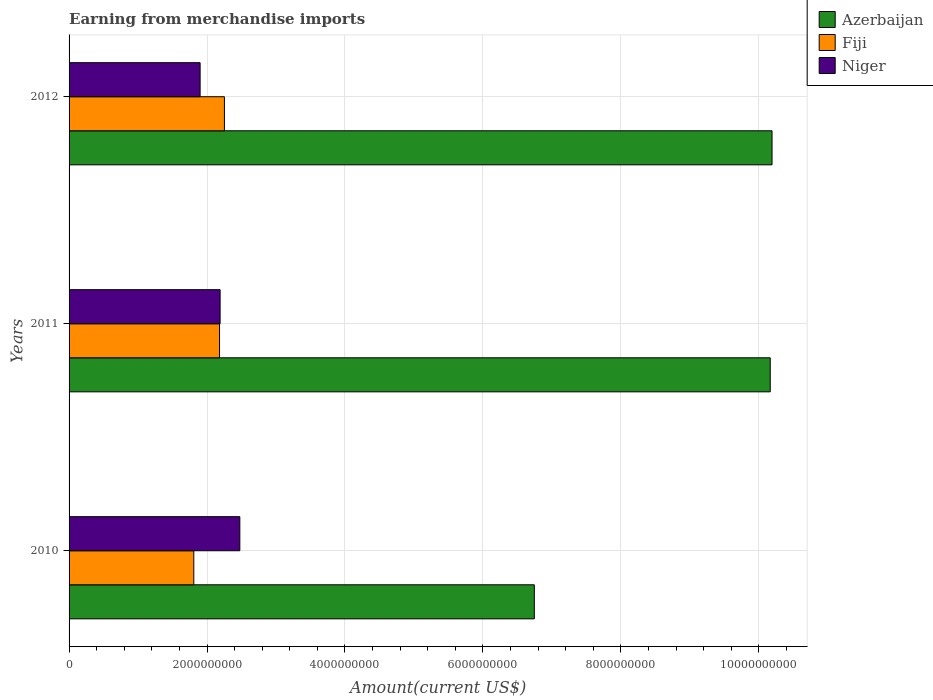How many different coloured bars are there?
Offer a very short reply. 3. How many groups of bars are there?
Your answer should be very brief. 3. Are the number of bars on each tick of the Y-axis equal?
Make the answer very short. Yes. What is the amount earned from merchandise imports in Fiji in 2010?
Ensure brevity in your answer.  1.81e+09. Across all years, what is the maximum amount earned from merchandise imports in Fiji?
Keep it short and to the point. 2.25e+09. Across all years, what is the minimum amount earned from merchandise imports in Fiji?
Provide a short and direct response. 1.81e+09. What is the total amount earned from merchandise imports in Fiji in the graph?
Ensure brevity in your answer.  6.24e+09. What is the difference between the amount earned from merchandise imports in Niger in 2010 and that in 2012?
Provide a succinct answer. 5.76e+08. What is the difference between the amount earned from merchandise imports in Azerbaijan in 2010 and the amount earned from merchandise imports in Niger in 2012?
Offer a terse response. 4.85e+09. What is the average amount earned from merchandise imports in Fiji per year?
Give a very brief answer. 2.08e+09. In the year 2012, what is the difference between the amount earned from merchandise imports in Fiji and amount earned from merchandise imports in Azerbaijan?
Provide a short and direct response. -7.94e+09. What is the ratio of the amount earned from merchandise imports in Azerbaijan in 2011 to that in 2012?
Your response must be concise. 1. Is the amount earned from merchandise imports in Fiji in 2010 less than that in 2012?
Your response must be concise. Yes. What is the difference between the highest and the second highest amount earned from merchandise imports in Niger?
Your response must be concise. 2.86e+08. What is the difference between the highest and the lowest amount earned from merchandise imports in Fiji?
Keep it short and to the point. 4.44e+08. In how many years, is the amount earned from merchandise imports in Niger greater than the average amount earned from merchandise imports in Niger taken over all years?
Offer a terse response. 2. Is the sum of the amount earned from merchandise imports in Niger in 2010 and 2011 greater than the maximum amount earned from merchandise imports in Azerbaijan across all years?
Offer a very short reply. No. What does the 1st bar from the top in 2010 represents?
Provide a short and direct response. Niger. What does the 2nd bar from the bottom in 2012 represents?
Give a very brief answer. Fiji. Are the values on the major ticks of X-axis written in scientific E-notation?
Your answer should be compact. No. Does the graph contain any zero values?
Keep it short and to the point. No. Where does the legend appear in the graph?
Offer a very short reply. Top right. How many legend labels are there?
Ensure brevity in your answer.  3. How are the legend labels stacked?
Offer a terse response. Vertical. What is the title of the graph?
Your answer should be compact. Earning from merchandise imports. What is the label or title of the X-axis?
Provide a succinct answer. Amount(current US$). What is the Amount(current US$) of Azerbaijan in 2010?
Your response must be concise. 6.75e+09. What is the Amount(current US$) of Fiji in 2010?
Provide a short and direct response. 1.81e+09. What is the Amount(current US$) of Niger in 2010?
Offer a terse response. 2.48e+09. What is the Amount(current US$) of Azerbaijan in 2011?
Your response must be concise. 1.02e+1. What is the Amount(current US$) in Fiji in 2011?
Provide a short and direct response. 2.18e+09. What is the Amount(current US$) of Niger in 2011?
Keep it short and to the point. 2.19e+09. What is the Amount(current US$) in Azerbaijan in 2012?
Your answer should be very brief. 1.02e+1. What is the Amount(current US$) in Fiji in 2012?
Give a very brief answer. 2.25e+09. What is the Amount(current US$) of Niger in 2012?
Offer a terse response. 1.90e+09. Across all years, what is the maximum Amount(current US$) in Azerbaijan?
Keep it short and to the point. 1.02e+1. Across all years, what is the maximum Amount(current US$) of Fiji?
Ensure brevity in your answer.  2.25e+09. Across all years, what is the maximum Amount(current US$) in Niger?
Make the answer very short. 2.48e+09. Across all years, what is the minimum Amount(current US$) in Azerbaijan?
Make the answer very short. 6.75e+09. Across all years, what is the minimum Amount(current US$) of Fiji?
Your response must be concise. 1.81e+09. Across all years, what is the minimum Amount(current US$) in Niger?
Keep it short and to the point. 1.90e+09. What is the total Amount(current US$) in Azerbaijan in the graph?
Your answer should be very brief. 2.71e+1. What is the total Amount(current US$) in Fiji in the graph?
Keep it short and to the point. 6.24e+09. What is the total Amount(current US$) in Niger in the graph?
Make the answer very short. 6.57e+09. What is the difference between the Amount(current US$) in Azerbaijan in 2010 and that in 2011?
Your answer should be compact. -3.42e+09. What is the difference between the Amount(current US$) of Fiji in 2010 and that in 2011?
Make the answer very short. -3.73e+08. What is the difference between the Amount(current US$) of Niger in 2010 and that in 2011?
Offer a terse response. 2.86e+08. What is the difference between the Amount(current US$) of Azerbaijan in 2010 and that in 2012?
Your answer should be very brief. -3.45e+09. What is the difference between the Amount(current US$) in Fiji in 2010 and that in 2012?
Your answer should be compact. -4.44e+08. What is the difference between the Amount(current US$) of Niger in 2010 and that in 2012?
Give a very brief answer. 5.76e+08. What is the difference between the Amount(current US$) of Azerbaijan in 2011 and that in 2012?
Provide a short and direct response. -2.60e+07. What is the difference between the Amount(current US$) in Fiji in 2011 and that in 2012?
Give a very brief answer. -7.07e+07. What is the difference between the Amount(current US$) of Niger in 2011 and that in 2012?
Provide a short and direct response. 2.90e+08. What is the difference between the Amount(current US$) in Azerbaijan in 2010 and the Amount(current US$) in Fiji in 2011?
Ensure brevity in your answer.  4.56e+09. What is the difference between the Amount(current US$) of Azerbaijan in 2010 and the Amount(current US$) of Niger in 2011?
Your answer should be compact. 4.56e+09. What is the difference between the Amount(current US$) of Fiji in 2010 and the Amount(current US$) of Niger in 2011?
Ensure brevity in your answer.  -3.82e+08. What is the difference between the Amount(current US$) in Azerbaijan in 2010 and the Amount(current US$) in Fiji in 2012?
Provide a succinct answer. 4.49e+09. What is the difference between the Amount(current US$) of Azerbaijan in 2010 and the Amount(current US$) of Niger in 2012?
Make the answer very short. 4.85e+09. What is the difference between the Amount(current US$) in Fiji in 2010 and the Amount(current US$) in Niger in 2012?
Offer a very short reply. -9.15e+07. What is the difference between the Amount(current US$) in Azerbaijan in 2011 and the Amount(current US$) in Fiji in 2012?
Provide a succinct answer. 7.91e+09. What is the difference between the Amount(current US$) in Azerbaijan in 2011 and the Amount(current US$) in Niger in 2012?
Give a very brief answer. 8.27e+09. What is the difference between the Amount(current US$) of Fiji in 2011 and the Amount(current US$) of Niger in 2012?
Offer a very short reply. 2.82e+08. What is the average Amount(current US$) in Azerbaijan per year?
Your answer should be very brief. 9.04e+09. What is the average Amount(current US$) of Fiji per year?
Keep it short and to the point. 2.08e+09. What is the average Amount(current US$) in Niger per year?
Your answer should be very brief. 2.19e+09. In the year 2010, what is the difference between the Amount(current US$) of Azerbaijan and Amount(current US$) of Fiji?
Your answer should be compact. 4.94e+09. In the year 2010, what is the difference between the Amount(current US$) of Azerbaijan and Amount(current US$) of Niger?
Give a very brief answer. 4.27e+09. In the year 2010, what is the difference between the Amount(current US$) in Fiji and Amount(current US$) in Niger?
Keep it short and to the point. -6.67e+08. In the year 2011, what is the difference between the Amount(current US$) of Azerbaijan and Amount(current US$) of Fiji?
Your answer should be very brief. 7.98e+09. In the year 2011, what is the difference between the Amount(current US$) in Azerbaijan and Amount(current US$) in Niger?
Your response must be concise. 7.98e+09. In the year 2011, what is the difference between the Amount(current US$) in Fiji and Amount(current US$) in Niger?
Your response must be concise. -8.13e+06. In the year 2012, what is the difference between the Amount(current US$) in Azerbaijan and Amount(current US$) in Fiji?
Give a very brief answer. 7.94e+09. In the year 2012, what is the difference between the Amount(current US$) of Azerbaijan and Amount(current US$) of Niger?
Offer a terse response. 8.29e+09. In the year 2012, what is the difference between the Amount(current US$) of Fiji and Amount(current US$) of Niger?
Your response must be concise. 3.53e+08. What is the ratio of the Amount(current US$) of Azerbaijan in 2010 to that in 2011?
Offer a terse response. 0.66. What is the ratio of the Amount(current US$) in Fiji in 2010 to that in 2011?
Ensure brevity in your answer.  0.83. What is the ratio of the Amount(current US$) of Niger in 2010 to that in 2011?
Your answer should be very brief. 1.13. What is the ratio of the Amount(current US$) of Azerbaijan in 2010 to that in 2012?
Make the answer very short. 0.66. What is the ratio of the Amount(current US$) of Fiji in 2010 to that in 2012?
Make the answer very short. 0.8. What is the ratio of the Amount(current US$) of Niger in 2010 to that in 2012?
Keep it short and to the point. 1.3. What is the ratio of the Amount(current US$) in Fiji in 2011 to that in 2012?
Provide a succinct answer. 0.97. What is the ratio of the Amount(current US$) of Niger in 2011 to that in 2012?
Provide a short and direct response. 1.15. What is the difference between the highest and the second highest Amount(current US$) of Azerbaijan?
Your answer should be very brief. 2.60e+07. What is the difference between the highest and the second highest Amount(current US$) of Fiji?
Give a very brief answer. 7.07e+07. What is the difference between the highest and the second highest Amount(current US$) in Niger?
Your response must be concise. 2.86e+08. What is the difference between the highest and the lowest Amount(current US$) of Azerbaijan?
Give a very brief answer. 3.45e+09. What is the difference between the highest and the lowest Amount(current US$) in Fiji?
Ensure brevity in your answer.  4.44e+08. What is the difference between the highest and the lowest Amount(current US$) in Niger?
Keep it short and to the point. 5.76e+08. 